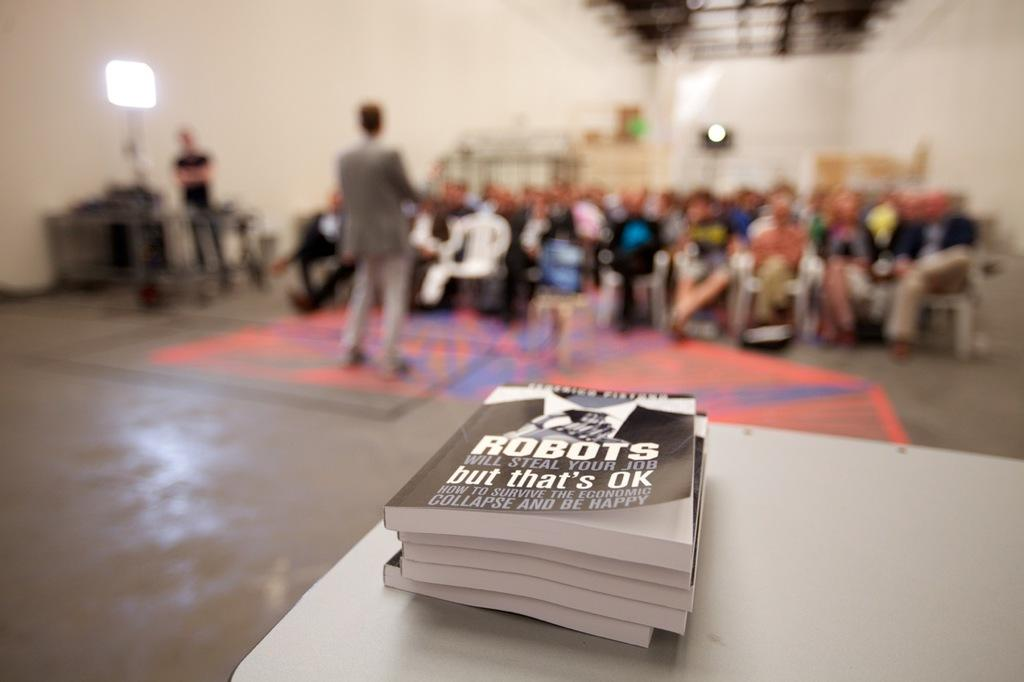<image>
Create a compact narrative representing the image presented. A stack of books titled Robots will steal your job, but that's ok, as a man speaks to a group of people in the background. 